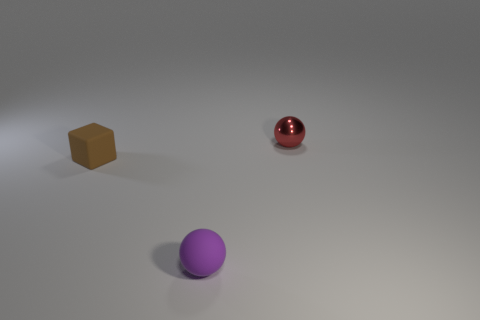What is the shape of the small object in front of the matte object that is on the left side of the small sphere left of the red sphere? The shape of the small object in front of the matte cube, which is on the left side of the small purple sphere and to the left of the red sphere, is a cube. It appears to be an ochre or tan-colored cube with a matte finish, and it is smaller in size compared to the two spheres. 